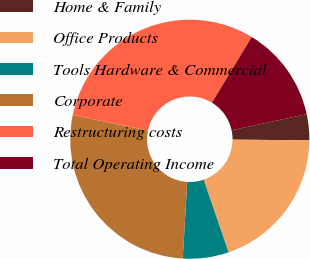<chart> <loc_0><loc_0><loc_500><loc_500><pie_chart><fcel>Home & Family<fcel>Office Products<fcel>Tools Hardware & Commercial<fcel>Corporate<fcel>Restructuring costs<fcel>Total Operating Income<nl><fcel>3.51%<fcel>19.6%<fcel>6.2%<fcel>27.3%<fcel>30.41%<fcel>12.97%<nl></chart> 